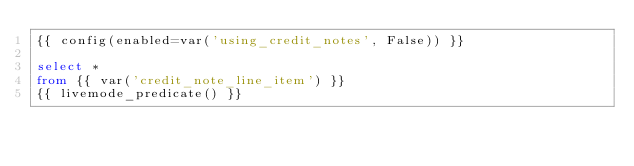<code> <loc_0><loc_0><loc_500><loc_500><_SQL_>{{ config(enabled=var('using_credit_notes', False)) }}

select * 
from {{ var('credit_note_line_item') }}
{{ livemode_predicate() }}</code> 